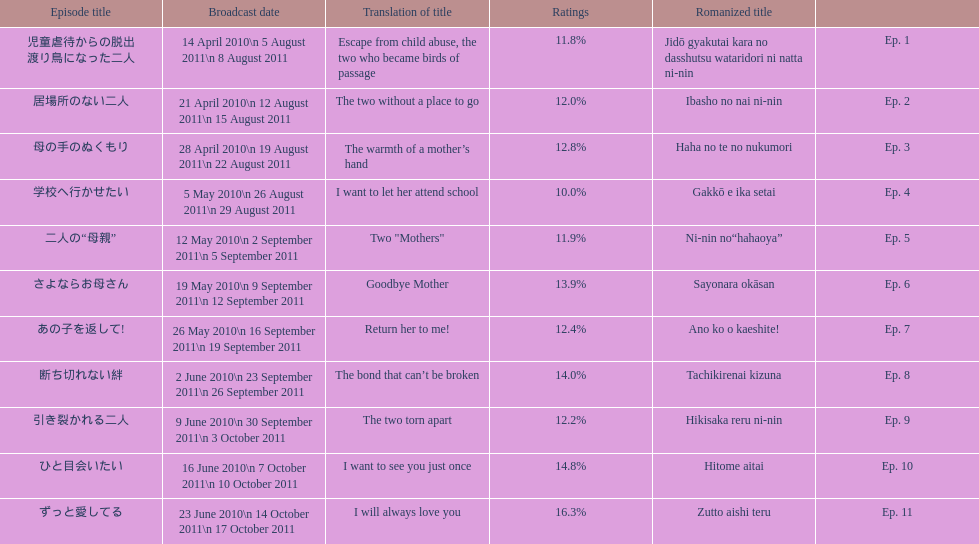What episode number was the only episode to have over 16% of ratings? 11. Could you help me parse every detail presented in this table? {'header': ['Episode title', 'Broadcast date', 'Translation of title', 'Ratings', 'Romanized title', ''], 'rows': [['児童虐待からの脱出 渡り鳥になった二人', '14 April 2010\\n 5 August 2011\\n 8 August 2011', 'Escape from child abuse, the two who became birds of passage', '11.8%', 'Jidō gyakutai kara no dasshutsu wataridori ni natta ni-nin', 'Ep. 1'], ['居場所のない二人', '21 April 2010\\n 12 August 2011\\n 15 August 2011', 'The two without a place to go', '12.0%', 'Ibasho no nai ni-nin', 'Ep. 2'], ['母の手のぬくもり', '28 April 2010\\n 19 August 2011\\n 22 August 2011', 'The warmth of a mother’s hand', '12.8%', 'Haha no te no nukumori', 'Ep. 3'], ['学校へ行かせたい', '5 May 2010\\n 26 August 2011\\n 29 August 2011', 'I want to let her attend school', '10.0%', 'Gakkō e ika setai', 'Ep. 4'], ['二人の“母親”', '12 May 2010\\n 2 September 2011\\n 5 September 2011', 'Two "Mothers"', '11.9%', 'Ni-nin no“hahaoya”', 'Ep. 5'], ['さよならお母さん', '19 May 2010\\n 9 September 2011\\n 12 September 2011', 'Goodbye Mother', '13.9%', 'Sayonara okāsan', 'Ep. 6'], ['あの子を返して!', '26 May 2010\\n 16 September 2011\\n 19 September 2011', 'Return her to me!', '12.4%', 'Ano ko o kaeshite!', 'Ep. 7'], ['断ち切れない絆', '2 June 2010\\n 23 September 2011\\n 26 September 2011', 'The bond that can’t be broken', '14.0%', 'Tachikirenai kizuna', 'Ep. 8'], ['引き裂かれる二人', '9 June 2010\\n 30 September 2011\\n 3 October 2011', 'The two torn apart', '12.2%', 'Hikisaka reru ni-nin', 'Ep. 9'], ['ひと目会いたい', '16 June 2010\\n 7 October 2011\\n 10 October 2011', 'I want to see you just once', '14.8%', 'Hitome aitai', 'Ep. 10'], ['ずっと愛してる', '23 June 2010\\n 14 October 2011\\n 17 October 2011', 'I will always love you', '16.3%', 'Zutto aishi teru', 'Ep. 11']]} 